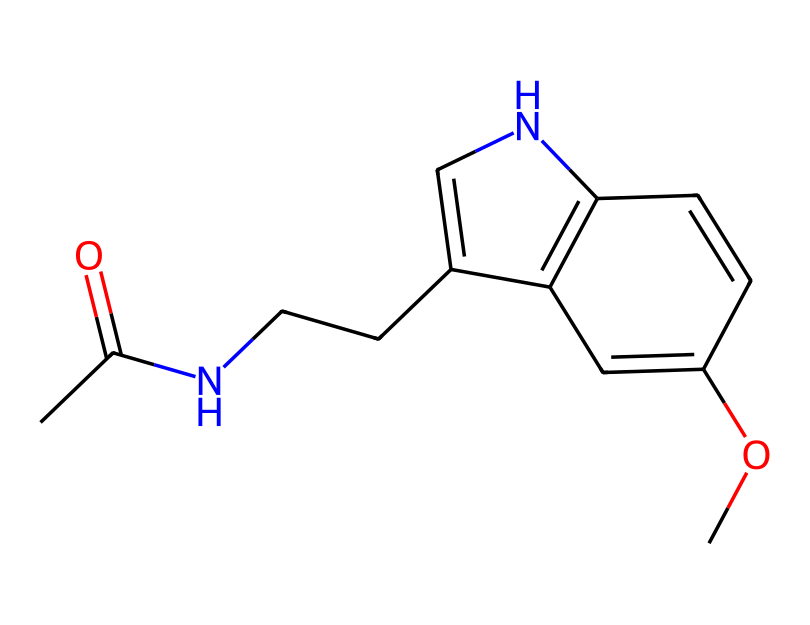What is the primary functional group present in this chemical? The chemical structure contains a carbonyl group (C=O) as indicated by the notation "CC(=O)" at the beginning of the SMILES, which points to the presence of an acetamide functional group as it pairs with the nitrogen.
Answer: acetamide How many nitrogen atoms are in the chemical structure? By examining the SMILES representation, we can identify two instances of nitrogen (N) within the structure—one in the amide and the other in the cyclic part of the molecule.
Answer: 2 What type of cycle is present in this structure? The structure contains a fused bicyclic ring system, as can be identified with "C1=CNc2c1" indicating it includes two connected cycles featuring nitrogen atoms, typical of bicyclic compounds.
Answer: bicyclic What is the maximum number of hydrogen atoms this molecule can have based on its structure? The molecule follows the general formula for calculating hydrogens: CnH2n+2, adjusting for double bonds and rings. With 13 carbons, this would yield a maximum of 28 hydrogens (i.e., 2(13)+2=28), but due to functional groups and structure, the actual number will be lower.
Answer: 14 Is this chemical likely soluble in water? The presence of polar functional groups, like the amide and methoxy (–OCH3) group, suggests it could have moderate solubility in water due to hydrogen bonding capabilities, even though larger hydrocarbon portions can hinder full solubility.
Answer: moderate What type of bonding primarily exists in this chemical structure? Given the SMILES notation indicates single and double bonds without metal components, we deduce that the primary bonding type in this molecule is covalent, common in organic compounds.
Answer: covalent Does this structure exhibit any stereochemistry? The SMILES does not indicate any chiral centers or geometric isomerism explicitly; however, specific geometrical arrangement around the double bond could suggest restricted rotation leading to potential geometric isomers, though none are noted.
Answer: no 